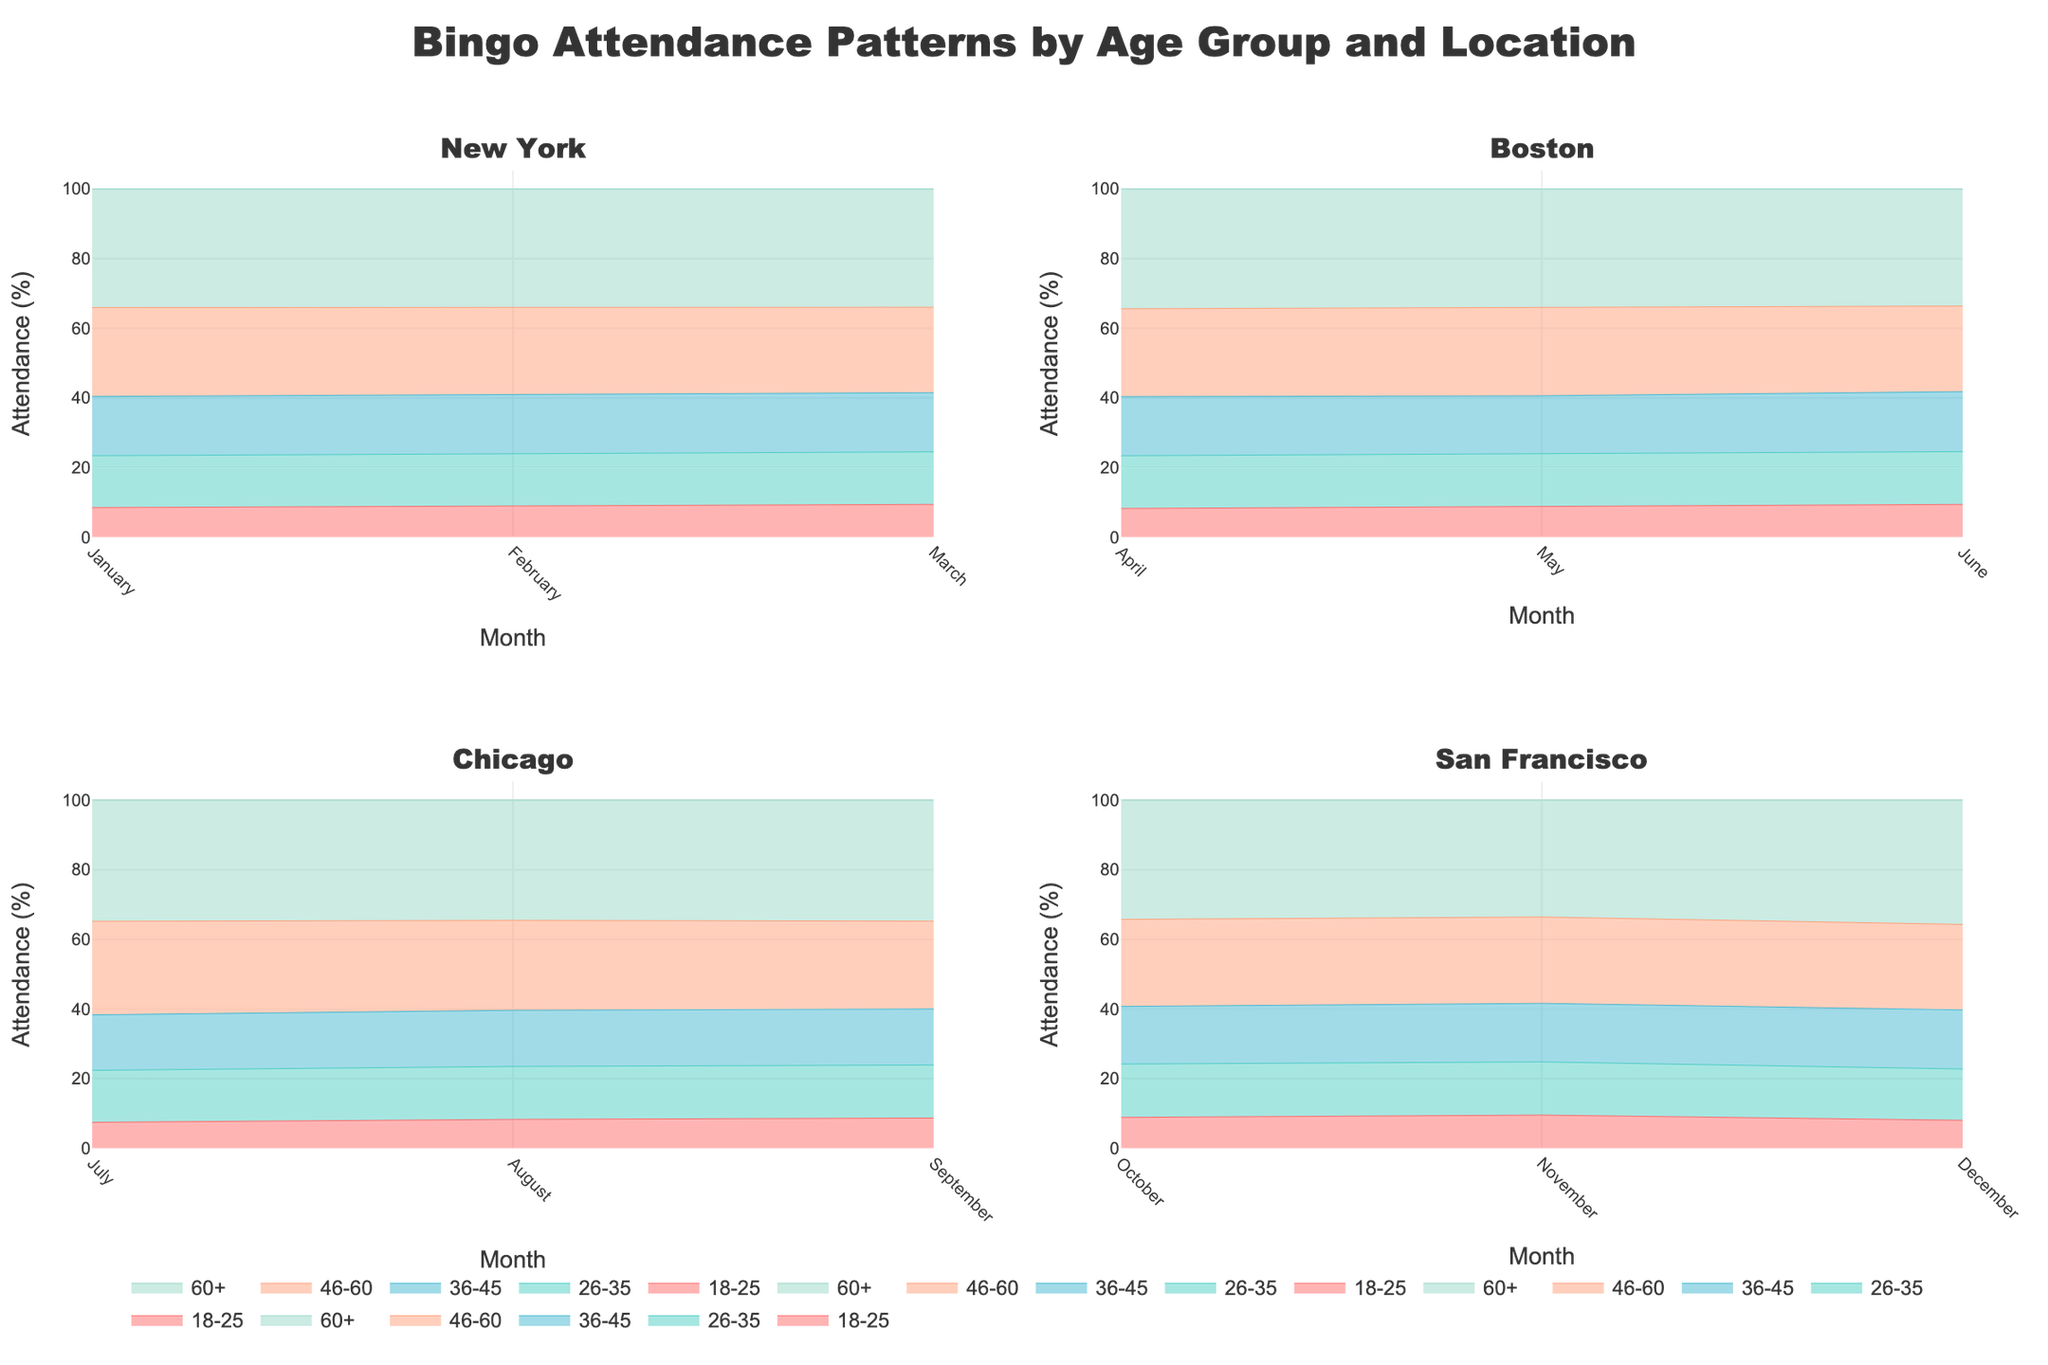What is the title of the figure? The title is usually located at the top of the figure. From the code, you can see that the title is set to "Bingo Attendance Patterns by Age Group and Location" with specific font features.
Answer: Bingo Attendance Patterns by Age Group and Location Which age group consistently has the highest attendance across all months? By examining the area plots across different locations, it is clear that the age group "60+" generally makes up the largest portion of the total attendance, represented by the largest area on the charts.
Answer: 60+ How does the attendance pattern for the age group "26-35" in March compare across all locations? For March, find the "26-35" age group in the subplots for New York, Boston, Chicago, and San Francisco. Calculate the attendance visually from each subplot. You will see that New York has 40, Boston has 33, Chicago is not represented, and San Francisco has no data for March. So, New York has the highest attendance for the "26-35" age group in March.
Answer: New York Which location shows the lowest attendance for the "18-25" age group in July? Look at the subplot for July and focus on the "18-25" age group. Only Chicago is shown in July with the attendance for this age group being 15, so it appears to be the lowest (and only) attendance.
Answer: Chicago In which month does the age group "46-60" have the highest percentage attendance in New York? Examine the subplot for New York and compare the "46-60" group's attendance each month. This group has the highest attendance in March within the subplot.
Answer: March Which age group has the smallest variation in attendance across all months in Boston? Look at the subplot for Boston and observe the patterns of each age group across all months. The "18-25" age group shows the smallest variation with attendance figures very close to each other from April to June.
Answer: 18-25 What trend can be observed for the age group "60+" in San Francisco? By examining the subplot for San Francisco specifically for the "60+" age group, it is clear that their attendance is fairly stable and maintains a high level across all months.
Answer: Stable high attendance Compare the attendance trends for the age group "36-45" between New York and Chicago. Look at the subplots for New York and Chicago and assess the attendance for the "36-45" age group across all months. New York shows a rising trend from January to March, while Chicago shows a generally stable attendance.
Answer: Rising in New York, Stable in Chicago How does the attendance in August for the "26-35" age group compare to September in Boston? There seems to be no data provided for Boston's attendance in August but in the code and data, September shows no data as well. Hence, it's could be a trick question to be aware of. For August there's no attendance shown for Boston. Cross checking it appropriately could lead to identifying the potential error in dataset too.
Answer: No Data Available Which location has the highest fluctuation in overall attendance? Assess the overall patterns for each age group in each subplot and compare the variability or fluctuation in the lines. San Francisco shows intermittent peaks and drops, indicating the highest fluctuations.
Answer: San Francisco 